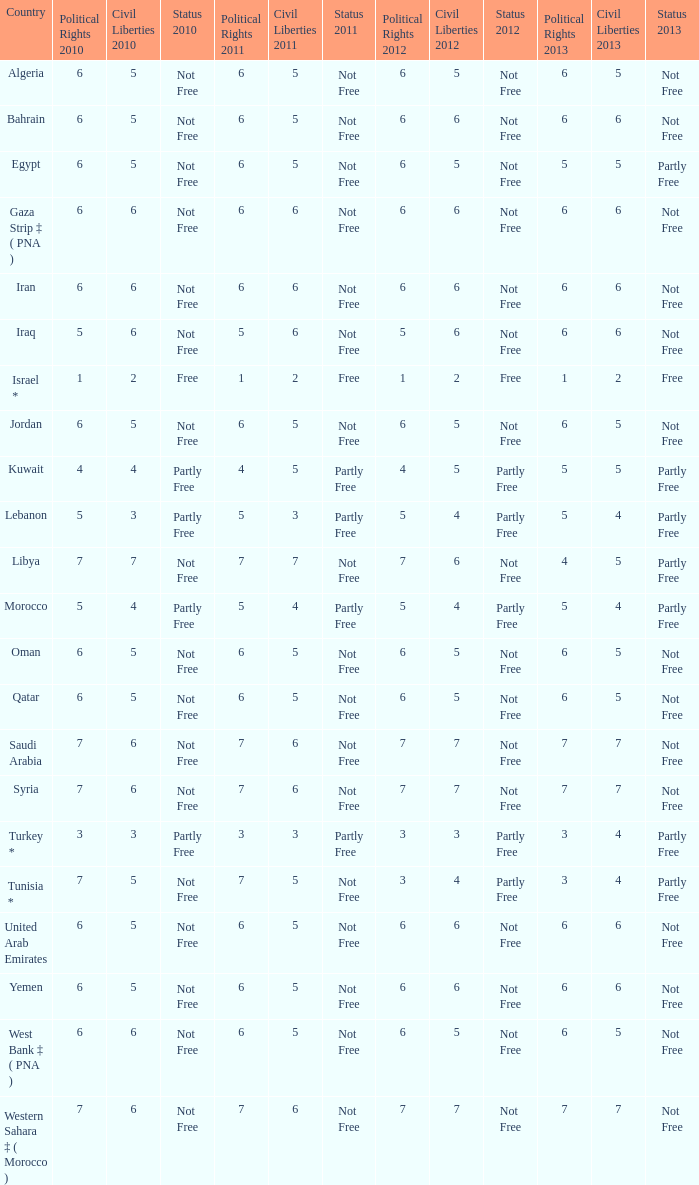What is the aggregate quantity of civil liberties with 2011 values that have 2010 political rights values less than 3 and 2011 political rights values less than 1? 0.0. 